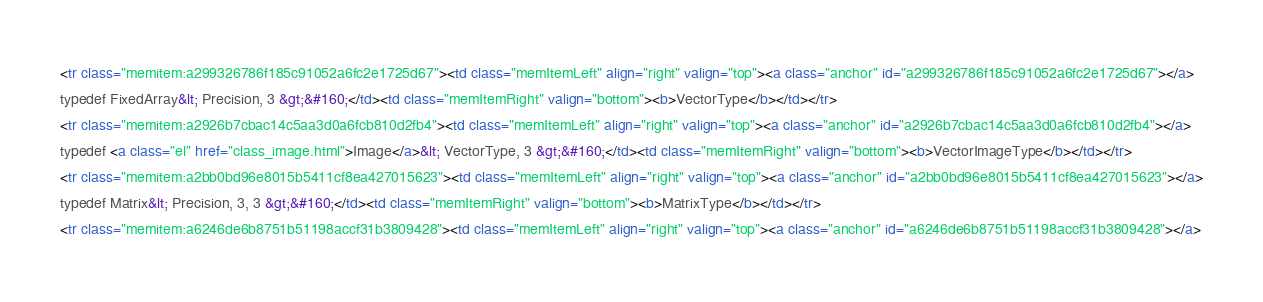Convert code to text. <code><loc_0><loc_0><loc_500><loc_500><_HTML_><tr class="memitem:a299326786f185c91052a6fc2e1725d67"><td class="memItemLeft" align="right" valign="top"><a class="anchor" id="a299326786f185c91052a6fc2e1725d67"></a>
typedef FixedArray&lt; Precision, 3 &gt;&#160;</td><td class="memItemRight" valign="bottom"><b>VectorType</b></td></tr>
<tr class="memitem:a2926b7cbac14c5aa3d0a6fcb810d2fb4"><td class="memItemLeft" align="right" valign="top"><a class="anchor" id="a2926b7cbac14c5aa3d0a6fcb810d2fb4"></a>
typedef <a class="el" href="class_image.html">Image</a>&lt; VectorType, 3 &gt;&#160;</td><td class="memItemRight" valign="bottom"><b>VectorImageType</b></td></tr>
<tr class="memitem:a2bb0bd96e8015b5411cf8ea427015623"><td class="memItemLeft" align="right" valign="top"><a class="anchor" id="a2bb0bd96e8015b5411cf8ea427015623"></a>
typedef Matrix&lt; Precision, 3, 3 &gt;&#160;</td><td class="memItemRight" valign="bottom"><b>MatrixType</b></td></tr>
<tr class="memitem:a6246de6b8751b51198accf31b3809428"><td class="memItemLeft" align="right" valign="top"><a class="anchor" id="a6246de6b8751b51198accf31b3809428"></a></code> 